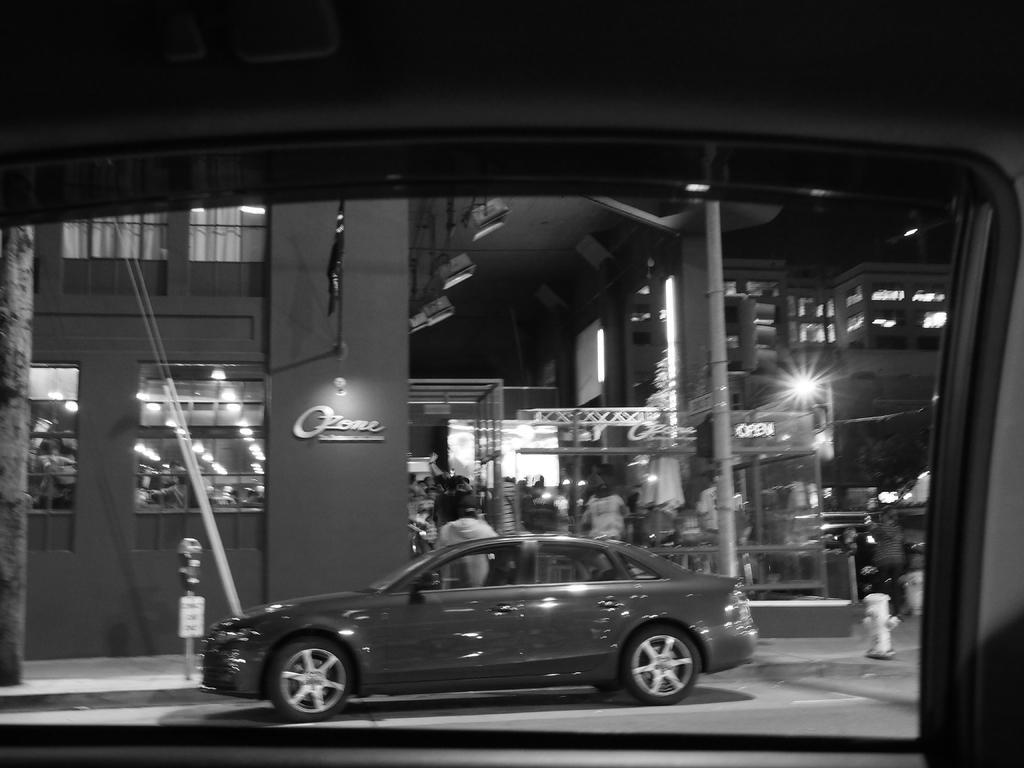Please provide a concise description of this image. Here in this picture, in the front we can see a window of a vehicle, through which we can see a car present on the road and in front of that we can see a parking meter present and beside that we can see buildings with windows present over there and we can also see number of people standing and walking on the road and we can see a pole present in the middle and we can also see a light post present and we can see plants and trees present. 